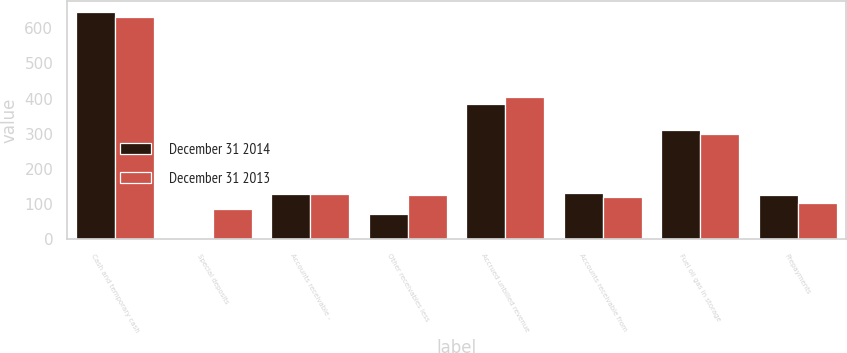Convert chart. <chart><loc_0><loc_0><loc_500><loc_500><stacked_bar_chart><ecel><fcel>Cash and temporary cash<fcel>Special deposits<fcel>Accounts receivable -<fcel>Other receivables less<fcel>Accrued unbilled revenue<fcel>Accounts receivable from<fcel>Fuel oil gas in storage<fcel>Prepayments<nl><fcel>December 31 2014<fcel>645<fcel>2<fcel>129.5<fcel>71<fcel>384<fcel>132<fcel>312<fcel>126<nl><fcel>December 31 2013<fcel>633<fcel>86<fcel>129.5<fcel>127<fcel>405<fcel>119<fcel>300<fcel>102<nl></chart> 